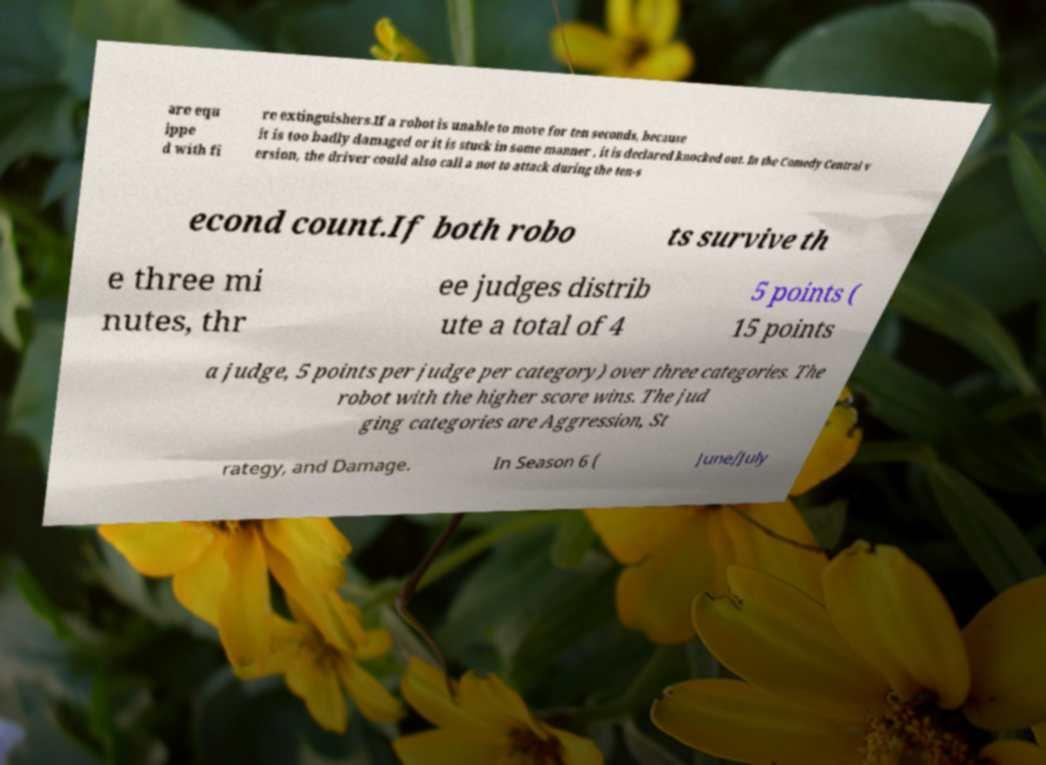There's text embedded in this image that I need extracted. Can you transcribe it verbatim? are equ ippe d with fi re extinguishers.If a robot is unable to move for ten seconds, because it is too badly damaged or it is stuck in some manner , it is declared knocked out. In the Comedy Central v ersion, the driver could also call a not to attack during the ten-s econd count.If both robo ts survive th e three mi nutes, thr ee judges distrib ute a total of 4 5 points ( 15 points a judge, 5 points per judge per category) over three categories. The robot with the higher score wins. The jud ging categories are Aggression, St rategy, and Damage. In Season 6 ( June/July 